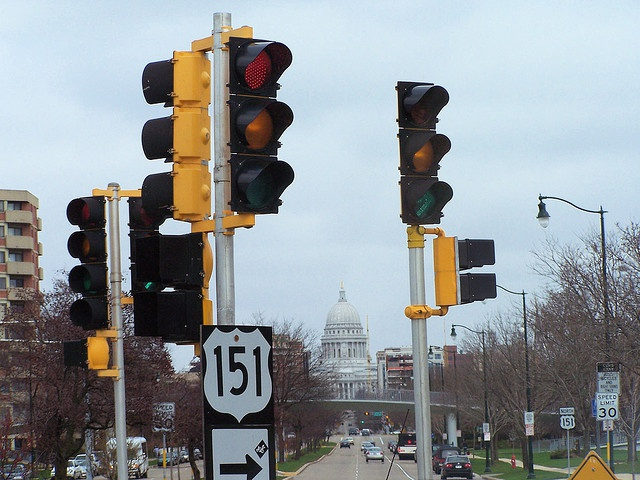Describe the objects in this image and their specific colors. I can see traffic light in lightblue, orange, black, and olive tones, traffic light in lightblue, black, maroon, and gray tones, traffic light in lightblue, black, gray, white, and darkgray tones, traffic light in lightblue, black, maroon, gray, and teal tones, and traffic light in lightgray, black, maroon, and gray tones in this image. 